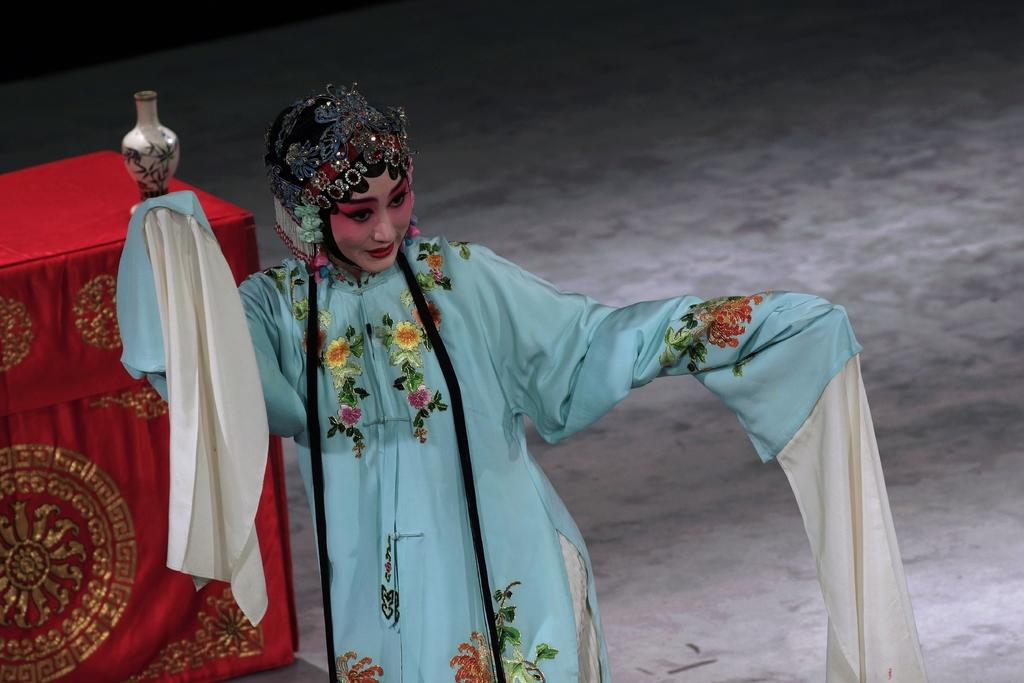Who is present in the image? There is a woman in the image. What is the woman doing in the image? The woman is standing on the ground. What is the woman wearing in the image? The woman is wearing a costume. What can be seen on the table in the image? There is a cloth spread on the table and a jar on the table. What type of cushion is being used for the action in the image? There is no action or cushion present in the image. 